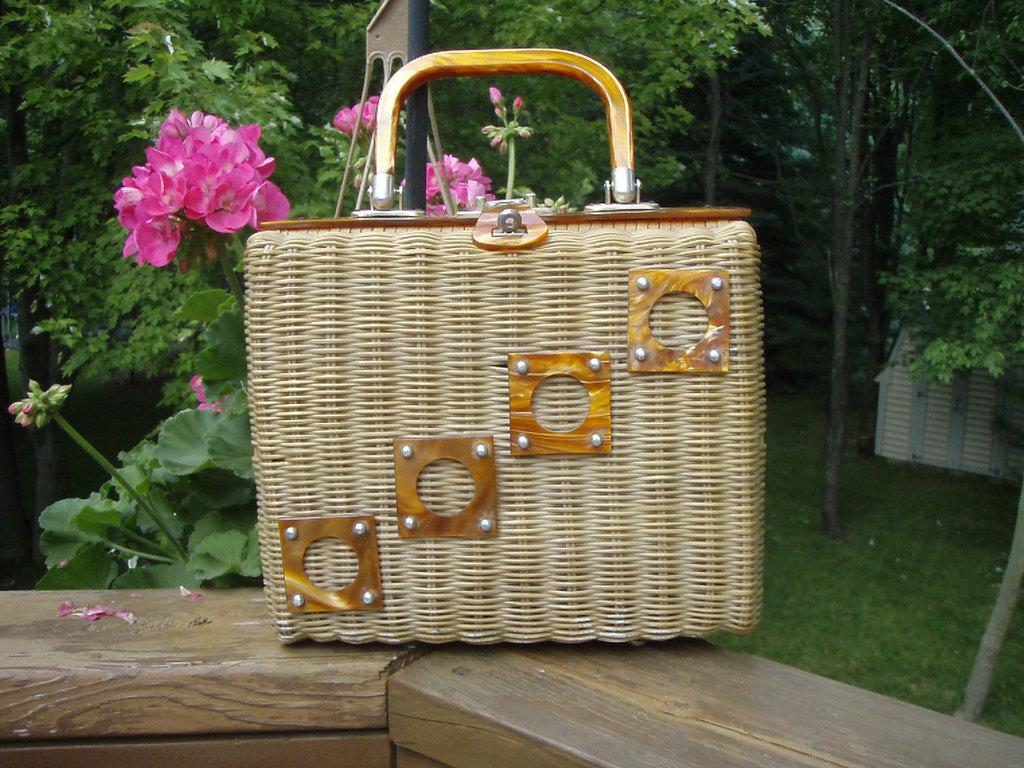What object is placed on the wooden platform in the image? There is a bag on a wooden platform in the image. What type of plants can be seen in the image? There are flowers in the image. What type of vegetation is visible on the ground in the image? There is grass visible in the image. What can be seen in the background of the image? There are trees in the background of the image. Can you tell me how many dogs are lifting the bag in the image? There are no dogs present in the image, and therefore no dogs are lifting the bag. 